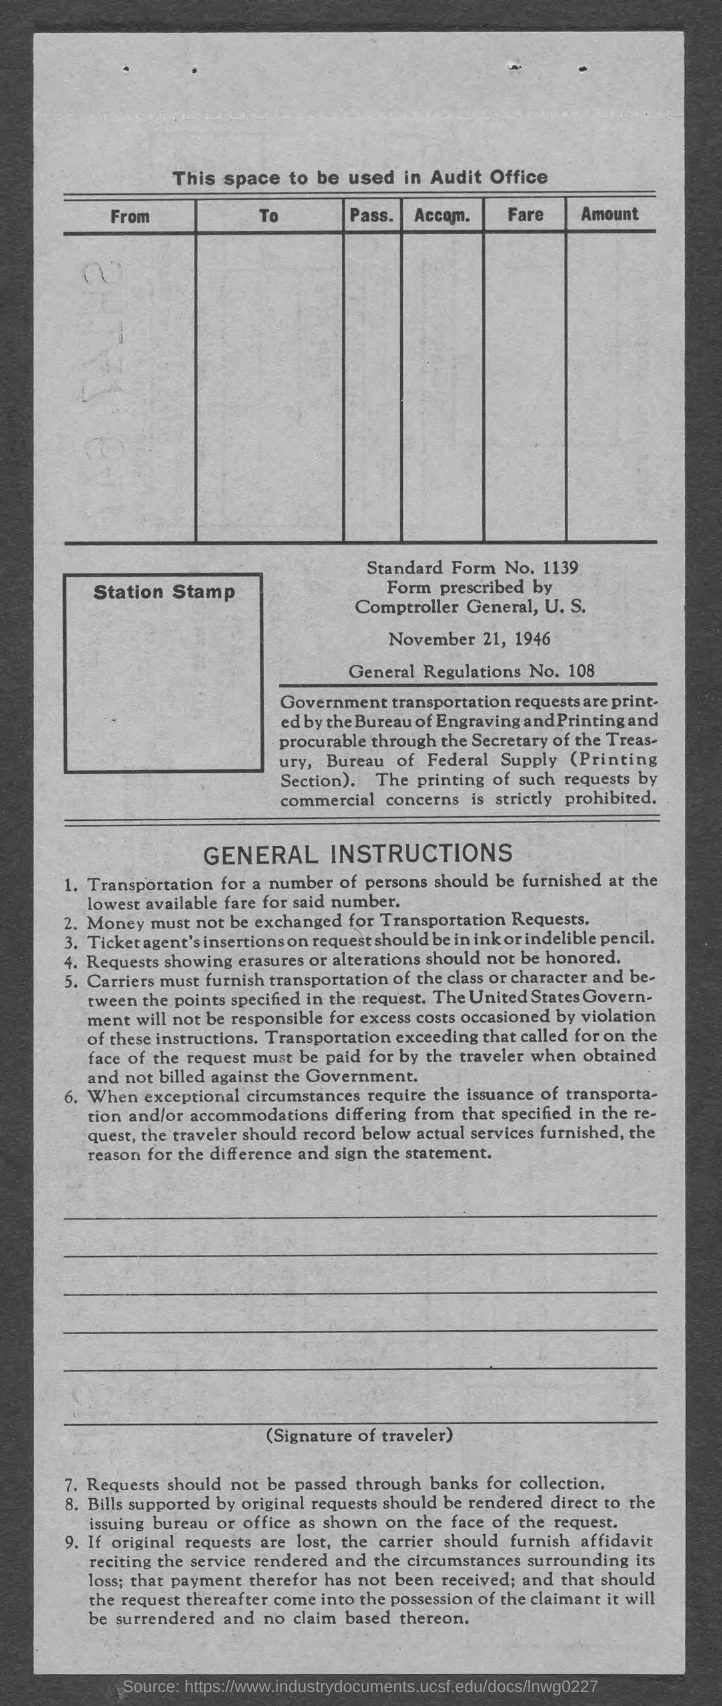List a handful of essential elements in this visual. The General Regulations number specified in the document is 108. The date mentioned in this document is November 21, 1946. The document contains a standard form number of 1139. 